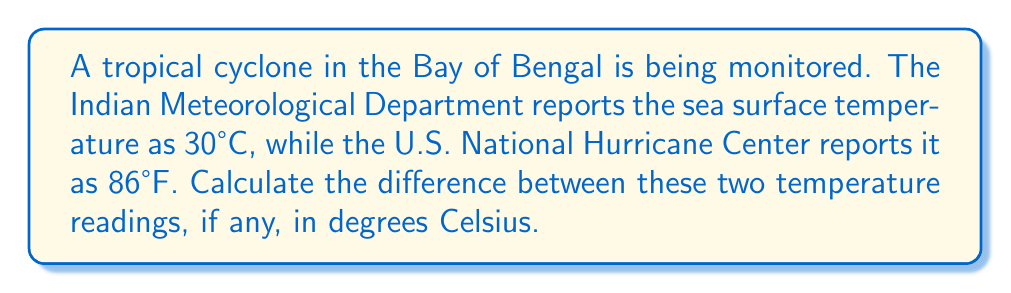Solve this math problem. To solve this problem, we need to convert the Fahrenheit temperature to Celsius and then compare the two values. Let's follow these steps:

1) First, recall the formula to convert Fahrenheit to Celsius:

   $$C = \frac{5}{9}(F - 32)$$

   Where $C$ is the temperature in Celsius and $F$ is the temperature in Fahrenheit.

2) We're given that the U.S. National Hurricane Center reports 86°F. Let's substitute this into our formula:

   $$C = \frac{5}{9}(86 - 32)$$

3) Simplify inside the parentheses:

   $$C = \frac{5}{9}(54)$$

4) Multiply:

   $$C = 30$$

5) So, 86°F is equivalent to 30°C.

6) The Indian Meteorological Department reported 30°C.

7) To find the difference, we subtract:

   $$30°C - 30°C = 0°C$$

Therefore, there is no difference between the two temperature readings.
Answer: 0°C 